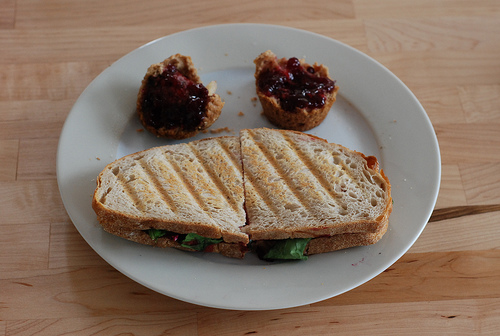Can you describe what the jam on the English muffins might be made from? The jam on the English muffins has a dark red color, which is typical of berry jams. It could be raspberry or blackberry jam, based on the visible seeds and the deep hue. 